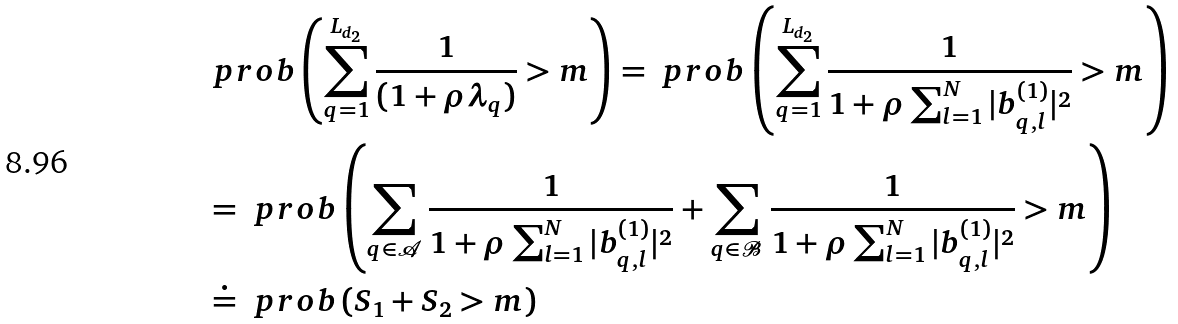<formula> <loc_0><loc_0><loc_500><loc_500>& \ p r o b \left ( \sum _ { q = 1 } ^ { L _ { d _ { 2 } } } \frac { 1 } { ( 1 + \rho \lambda _ { q } ) } > m \right ) = \ p r o b \left ( \sum _ { q = 1 } ^ { L _ { d _ { 2 } } } \frac { 1 } { 1 + \rho \sum _ { l = 1 } ^ { N } | b ^ { ( 1 ) } _ { q , l } | ^ { 2 } } > m \right ) \\ & = \ p r o b \left ( \sum _ { q \in { \mathcal { A } } } \frac { 1 } { 1 + \rho \sum _ { l = 1 } ^ { N } | b ^ { ( 1 ) } _ { q , l } | ^ { 2 } } + \sum _ { q \in \mathcal { B } } \frac { 1 } { 1 + \rho \sum _ { l = 1 } ^ { N } | b ^ { ( 1 ) } _ { q , l } | ^ { 2 } } > m \right ) \\ & \doteq \ p r o b \left ( S _ { 1 } + S _ { 2 } > m \right )</formula> 